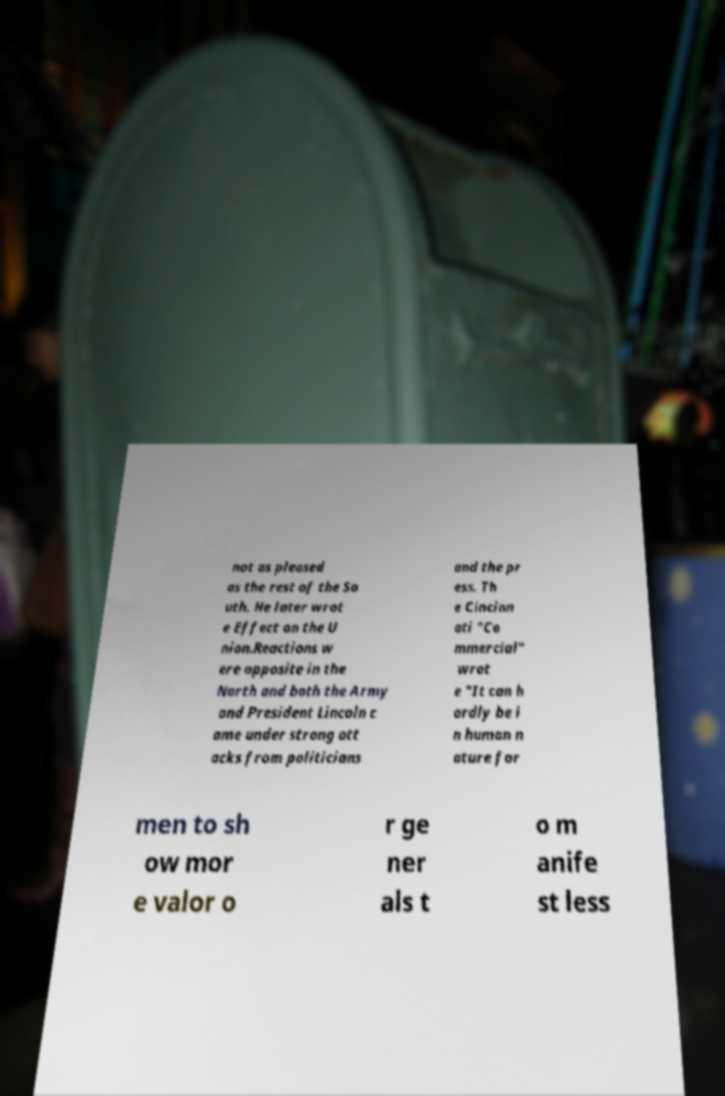Please identify and transcribe the text found in this image. not as pleased as the rest of the So uth. He later wrot e Effect on the U nion.Reactions w ere opposite in the North and both the Army and President Lincoln c ame under strong att acks from politicians and the pr ess. Th e Cincinn ati "Co mmercial" wrot e "It can h ardly be i n human n ature for men to sh ow mor e valor o r ge ner als t o m anife st less 